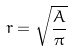<formula> <loc_0><loc_0><loc_500><loc_500>r = \sqrt { \frac { A } { \pi } }</formula> 